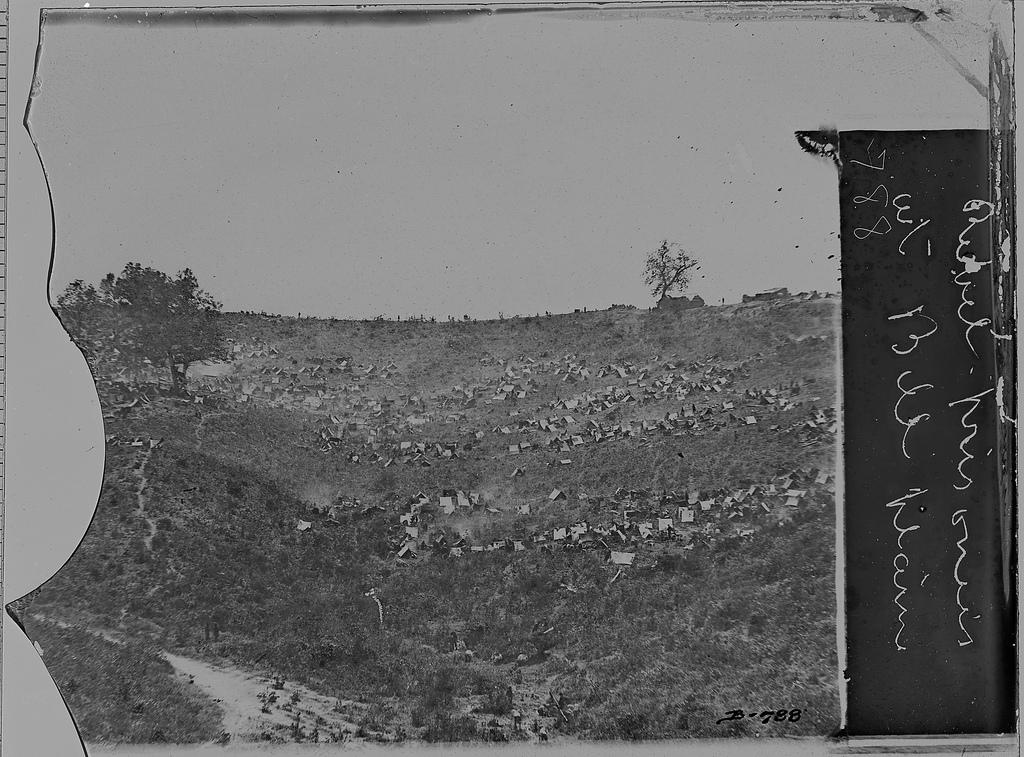What type of image is shown in the photograph? The image is a black and white photograph. What is the main subject of the photograph? The photograph depicts the ground. What type of vegetation can be seen in the photograph? There are trees and grass in the photograph. Is there any text present in the photograph? Yes, there is text written in the right corner of the photograph. Can you see any sand in the photograph? No, there is no sand visible in the photograph. Is there a hospital depicted in the photograph? No, there is no hospital present in the photograph. 